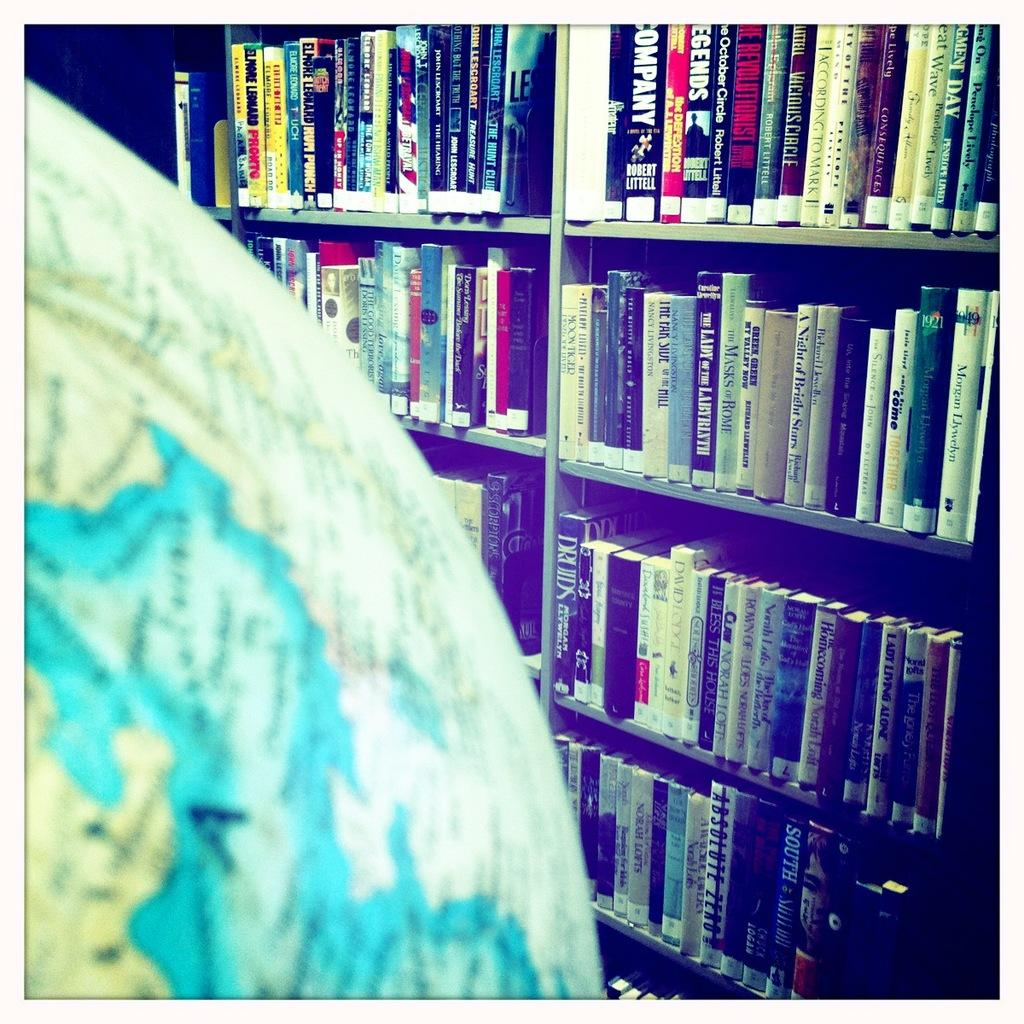What objects are present in the image? There are books in the image. How are the books organized or stored? The books are in racks. What type of breakfast is being prepared in the image? There is no breakfast preparation visible in the image; it only features books in racks. 